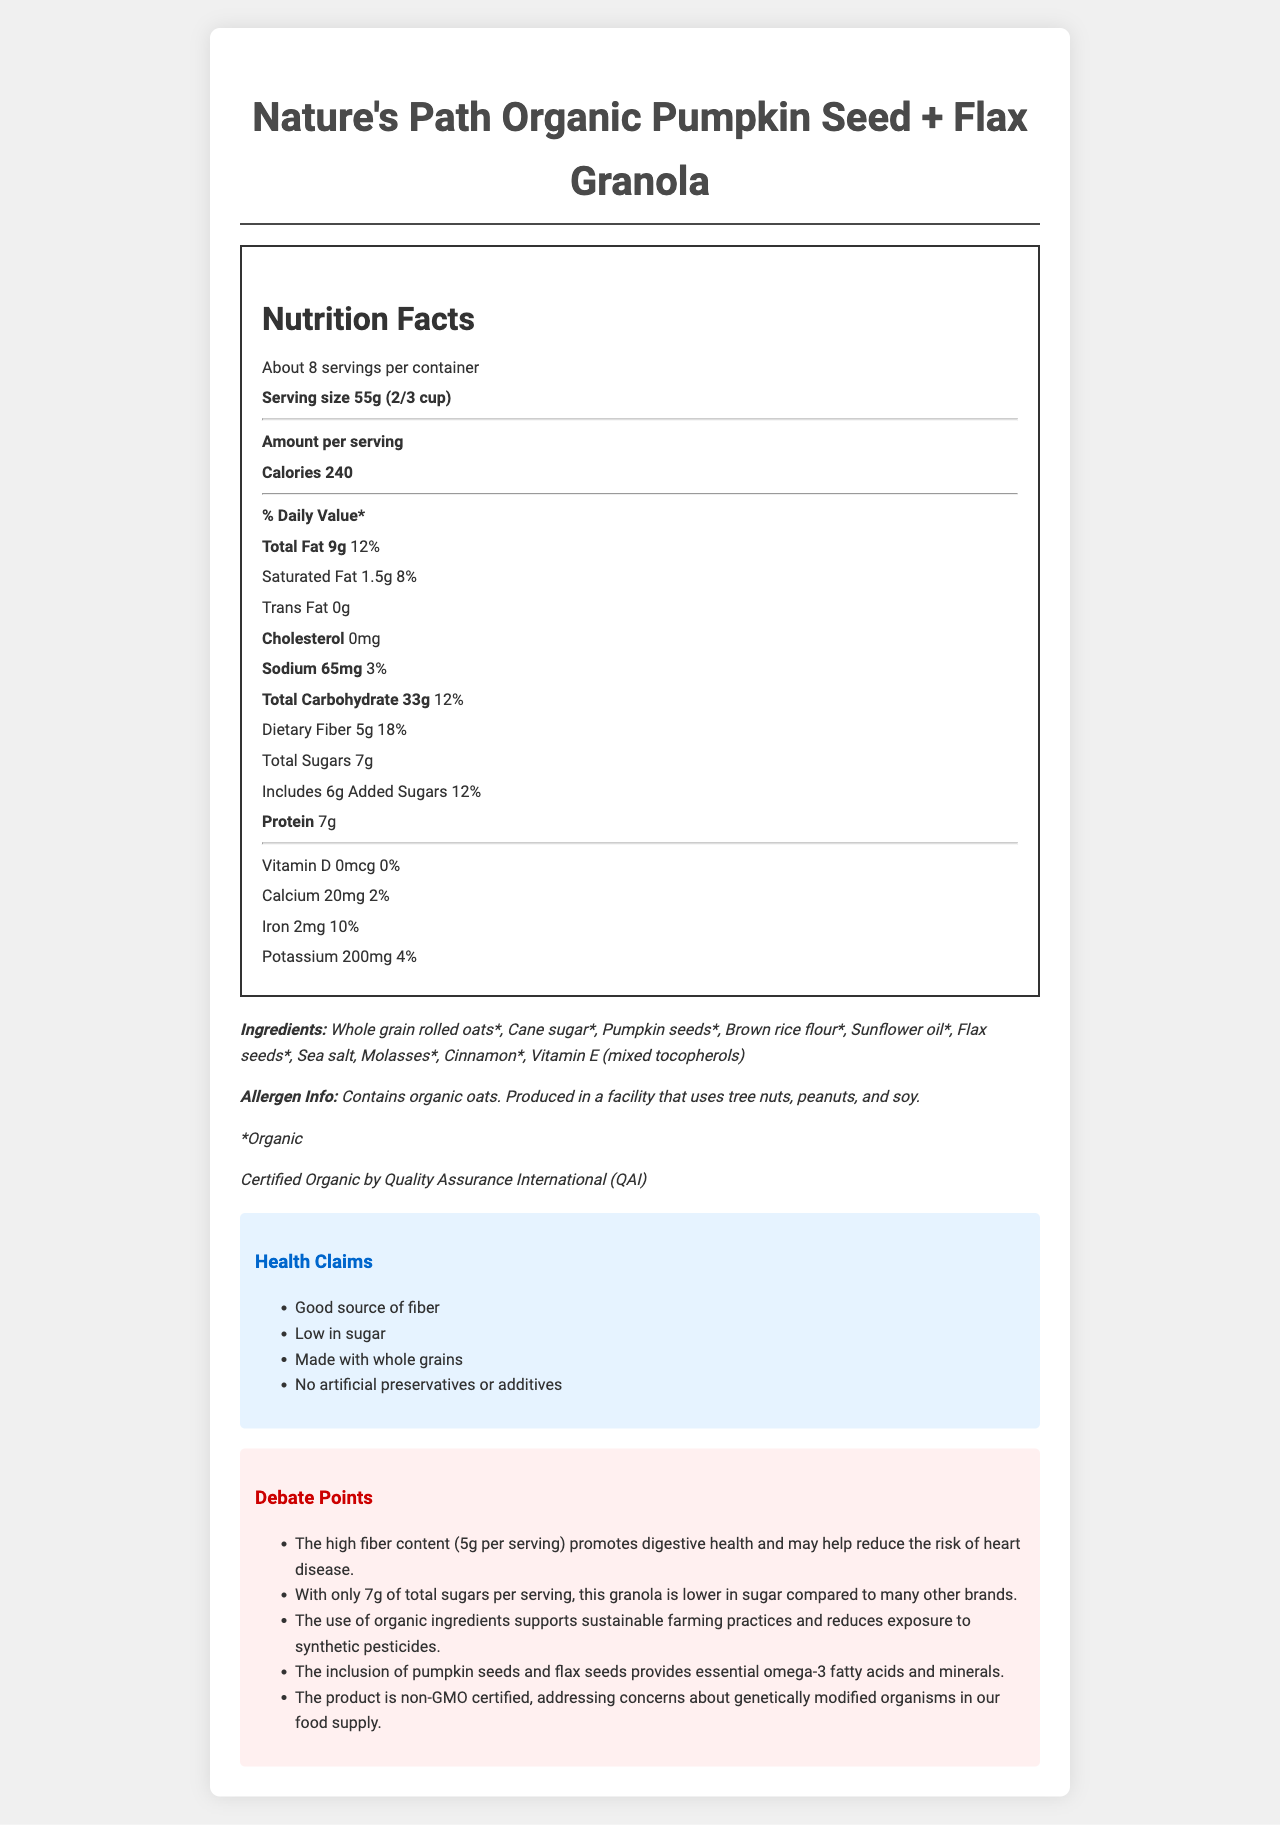what is the serving size of the granola? The serving size is clearly indicated at the top of the nutrition label as "55g (2/3 cup)".
Answer: 55g (2/3 cup) how many calories are in a serving of this granola? The document states "Calories 240" under the nutrition label.
Answer: 240 calories what is the daily value percentage of dietary fiber? It is mentioned under the dietary fiber section of the nutrition label that it makes up 18% of the daily value.
Answer: 18% what are the main ingredients listed for this granola? The ingredients are listed under the "Ingredients" section of the document.
Answer: Whole grain rolled oats, Cane sugar, Pumpkin seeds, Brown rice flour, Sunflower oil, Flax seeds, Sea salt, Molasses, Cinnamon, Vitamin E how many grams of protein are in one serving? The nutrition label shows that one serving contains 7g of protein.
Answer: 7g how much saturated fat is in one serving? The nutrition label states that there is 1.5g of saturated fat in one serving.
Answer: 1.5g what percentage of daily value does calcium account for in this granola? The document lists calcium as contributing 2% to the daily value.
Answer: 2% which nutrient is not present in this granola? A. Vitamin D B. Iron C. Calcium D. Potassium Vitamin D is listed with a value of 0mcg and 0% daily value, indicating it is not present.
Answer: A. Vitamin D which of the following statements is true about the product? (i) It is low in fiber (ii) It contains added sugars (iii) It is high in cholesterol (iv) It is non-GMO certified The label mentions that the granola includes added sugars and is non-GMO certified, but it is not low in fiber and contains no cholesterol.
Answer: ii and iv is this granola organic? Under the ingredients section, it's noted that the product contains organic ingredients and is certified organic by QAI.
Answer: Yes what are the health claims associated with this granola? These claims are listed under the "Health Claims" section of the document.
Answer: Good source of fiber, Low in sugar, Made with whole grains, No artificial preservatives or additives summarize the main points presented in the document. The document provides comprehensive information on the nutritional content, ingredients, and health benefits of the granola, as well as certifications and allergen information.
Answer: The document provides a detailed nutrition facts label for Nature's Path Organic Pumpkin Seed + Flax Granola. It highlights the serving size and nutritional content per serving, including calories, fats, cholesterol, sodium, carbohydrates, dietary fiber, sugars, proteins, and various vitamins and minerals. It also lists the organic ingredients and outlines health claims promoting its high fiber content, low sugar levels, use of whole grains, and lack of artificial additives. Additionally, it presents the benefits of its organic and non-GMO certifications and mentions its production in a facility that uses tree nuts, peanuts, and soy. what is the process for certifying the product as non-GMO? The document states that it is non-GMO certified but does not provide details about the certification process.
Answer: Cannot be determined 